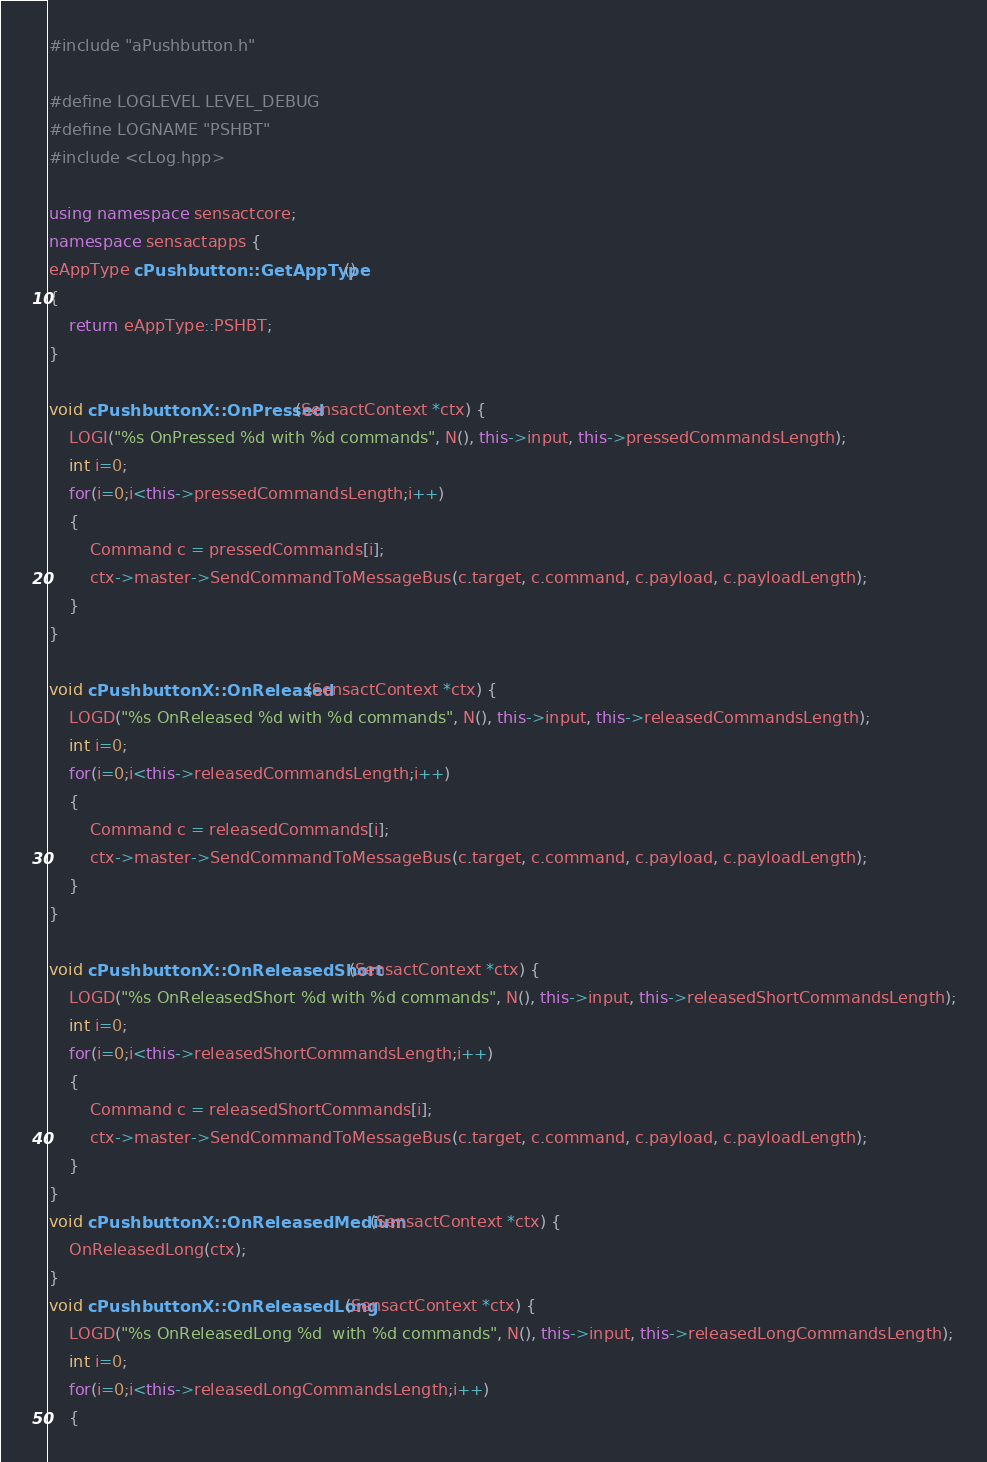<code> <loc_0><loc_0><loc_500><loc_500><_C++_>#include "aPushbutton.h"

#define LOGLEVEL LEVEL_DEBUG
#define LOGNAME "PSHBT"
#include <cLog.hpp>

using namespace sensactcore;
namespace sensactapps {
eAppType cPushbutton::GetAppType()
{
	return eAppType::PSHBT;
}

void cPushbuttonX::OnPressed(SensactContext *ctx) {
	LOGI("%s OnPressed %d with %d commands", N(), this->input, this->pressedCommandsLength);
	int i=0;
	for(i=0;i<this->pressedCommandsLength;i++)
	{
		Command c = pressedCommands[i];
		ctx->master->SendCommandToMessageBus(c.target, c.command, c.payload, c.payloadLength);
	}
}

void cPushbuttonX::OnReleased(SensactContext *ctx) {
	LOGD("%s OnReleased %d with %d commands", N(), this->input, this->releasedCommandsLength);
	int i=0;
	for(i=0;i<this->releasedCommandsLength;i++)
	{
		Command c = releasedCommands[i];
		ctx->master->SendCommandToMessageBus(c.target, c.command, c.payload, c.payloadLength);
	}
}

void cPushbuttonX::OnReleasedShort(SensactContext *ctx) {
	LOGD("%s OnReleasedShort %d with %d commands", N(), this->input, this->releasedShortCommandsLength);
	int i=0;
	for(i=0;i<this->releasedShortCommandsLength;i++)
	{
		Command c = releasedShortCommands[i];
		ctx->master->SendCommandToMessageBus(c.target, c.command, c.payload, c.payloadLength);
	}
}
void cPushbuttonX::OnReleasedMedium(SensactContext *ctx) {
	OnReleasedLong(ctx);
}
void cPushbuttonX::OnReleasedLong(SensactContext *ctx) {
	LOGD("%s OnReleasedLong %d  with %d commands", N(), this->input, this->releasedLongCommandsLength);
	int i=0;
	for(i=0;i<this->releasedLongCommandsLength;i++)
	{</code> 